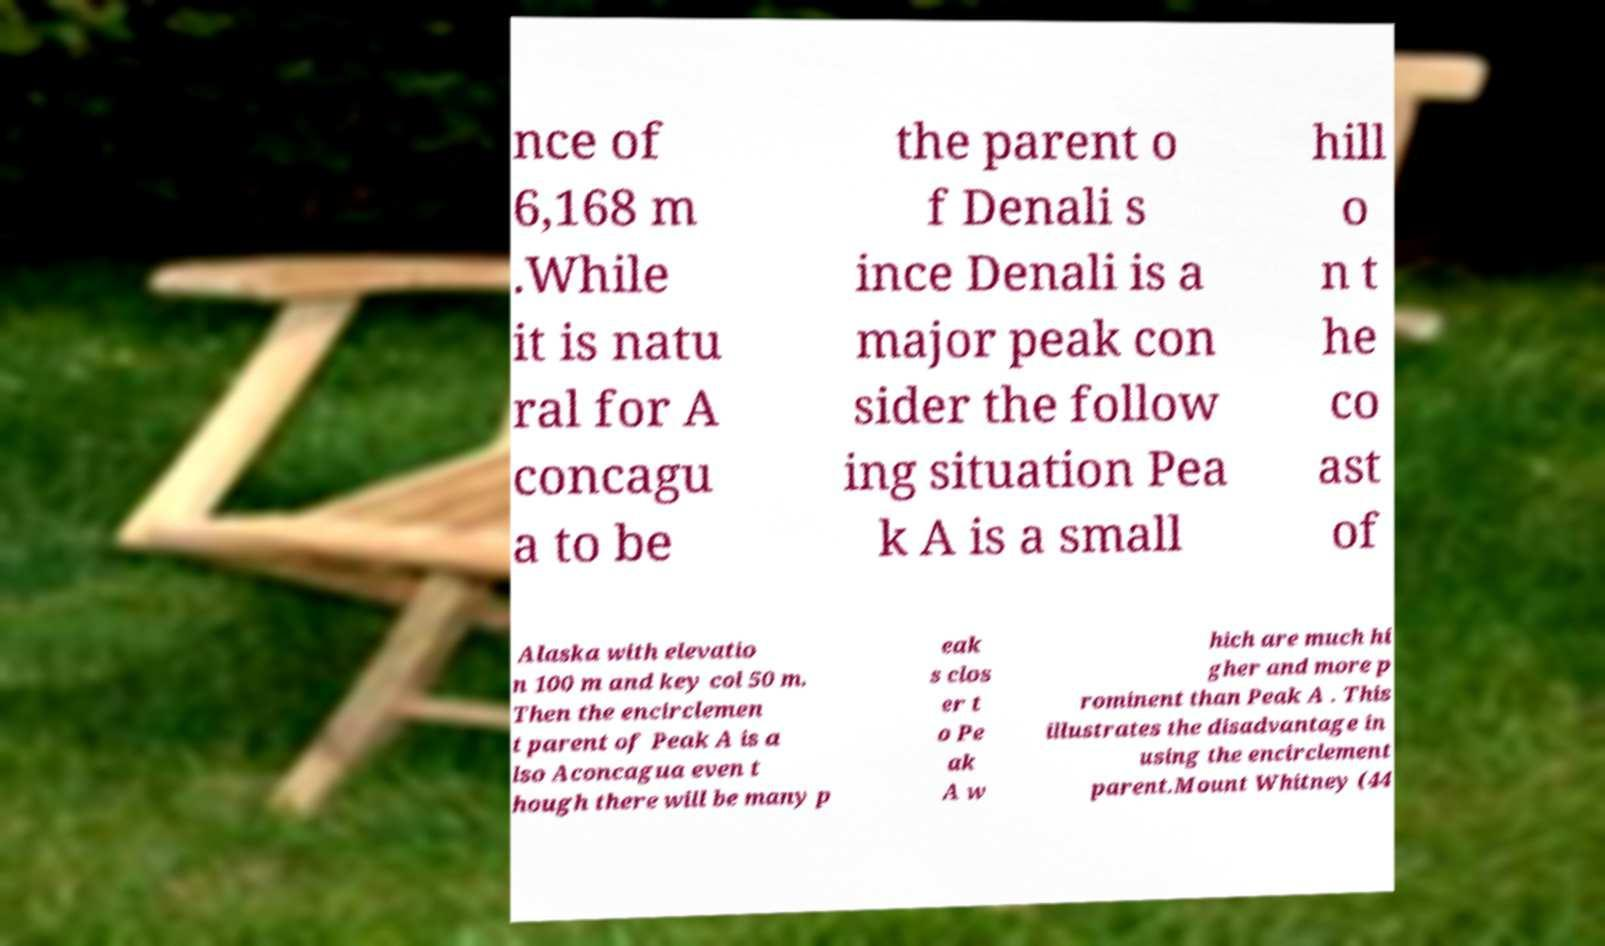Can you accurately transcribe the text from the provided image for me? nce of 6,168 m .While it is natu ral for A concagu a to be the parent o f Denali s ince Denali is a major peak con sider the follow ing situation Pea k A is a small hill o n t he co ast of Alaska with elevatio n 100 m and key col 50 m. Then the encirclemen t parent of Peak A is a lso Aconcagua even t hough there will be many p eak s clos er t o Pe ak A w hich are much hi gher and more p rominent than Peak A . This illustrates the disadvantage in using the encirclement parent.Mount Whitney (44 